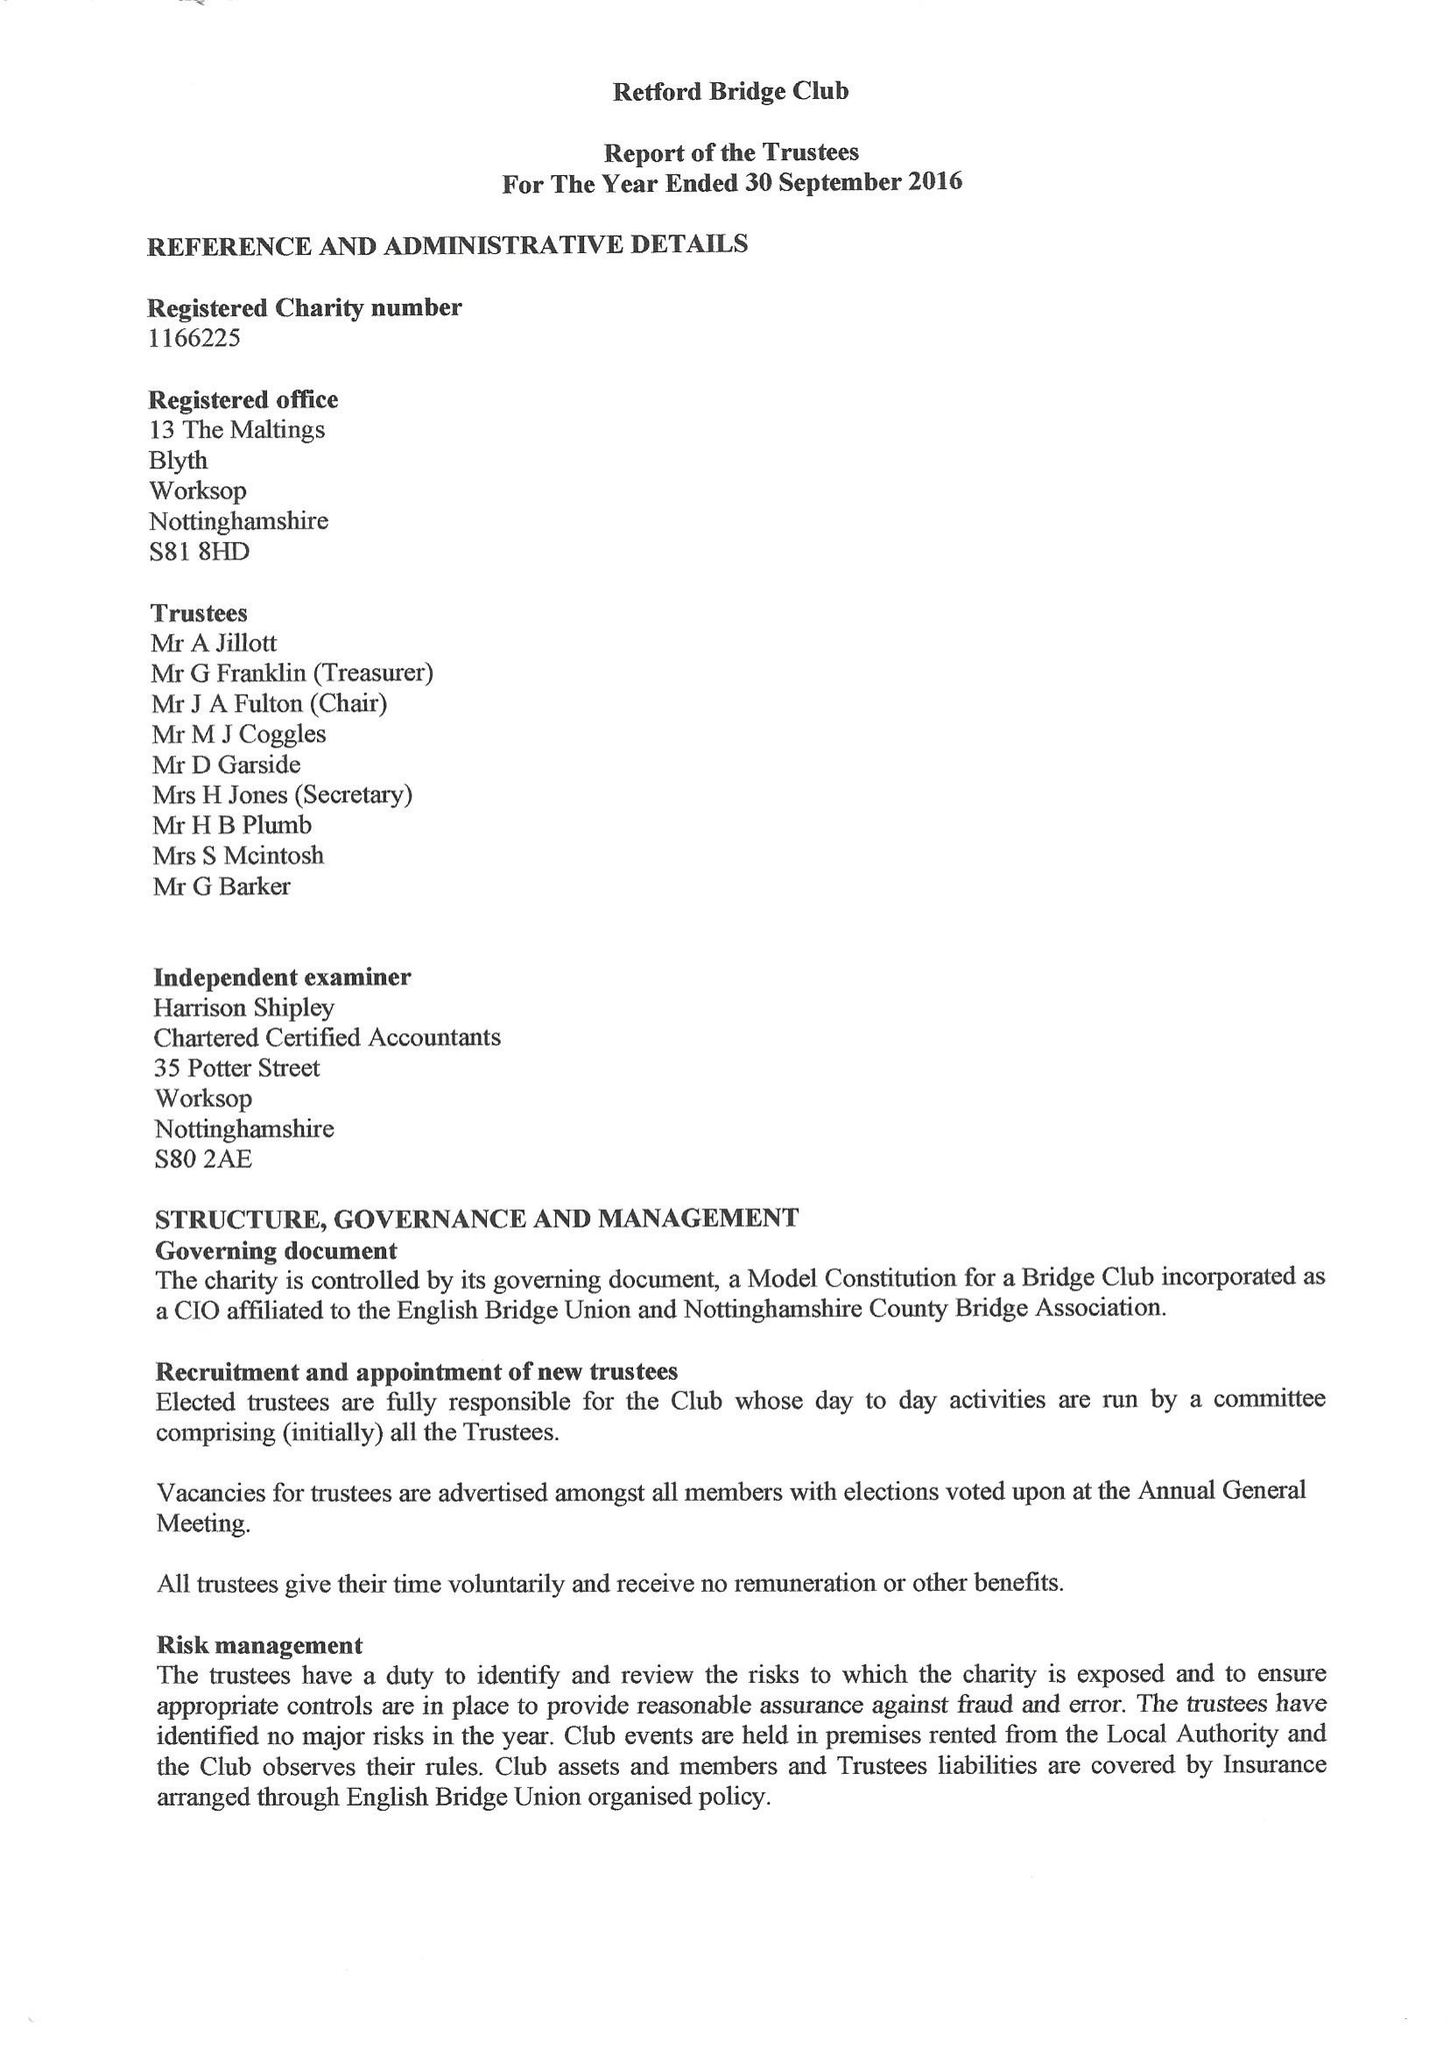What is the value for the charity_name?
Answer the question using a single word or phrase. Retford Bridge Club 